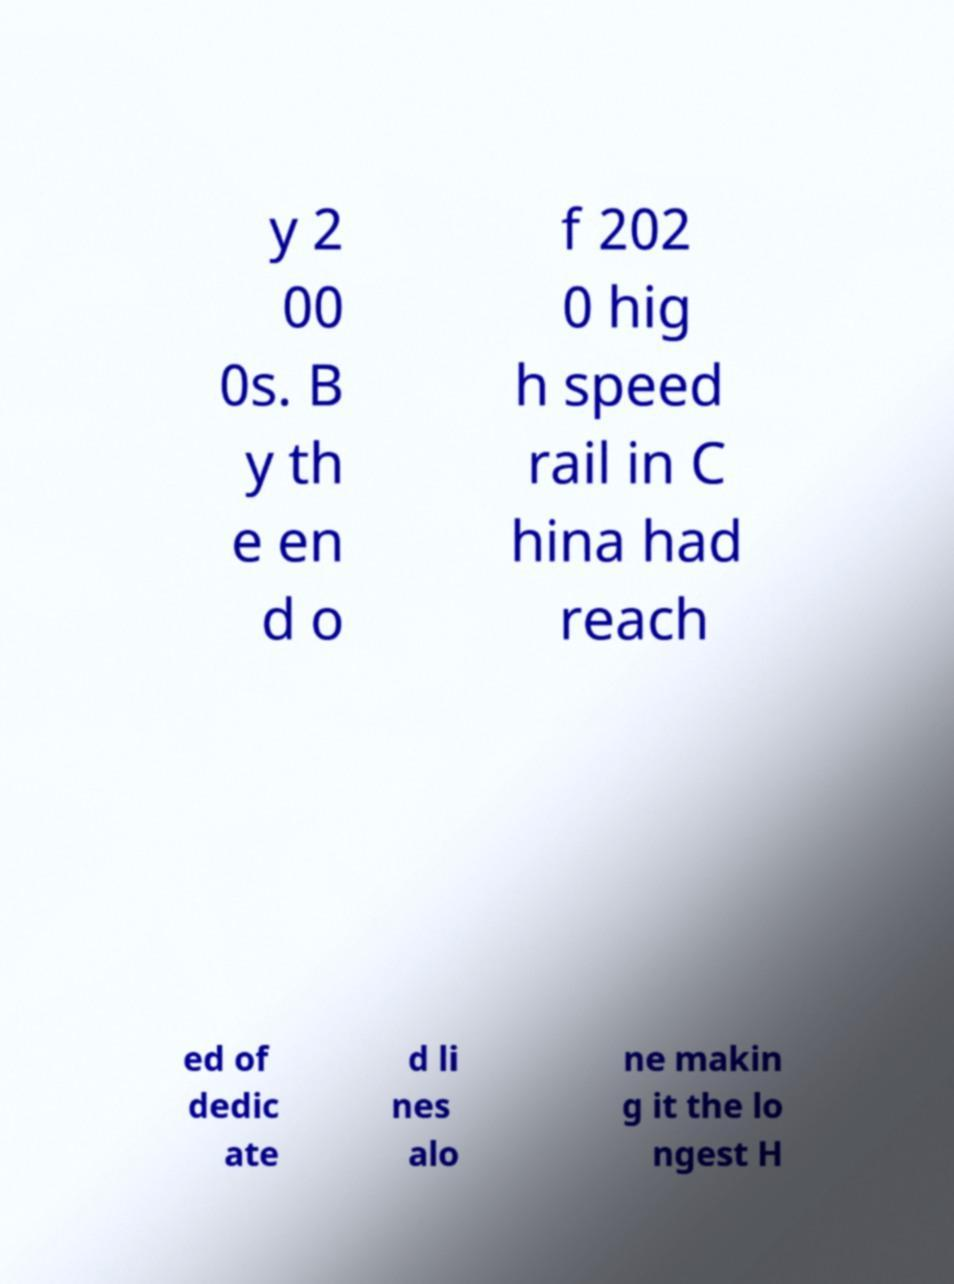For documentation purposes, I need the text within this image transcribed. Could you provide that? y 2 00 0s. B y th e en d o f 202 0 hig h speed rail in C hina had reach ed of dedic ate d li nes alo ne makin g it the lo ngest H 